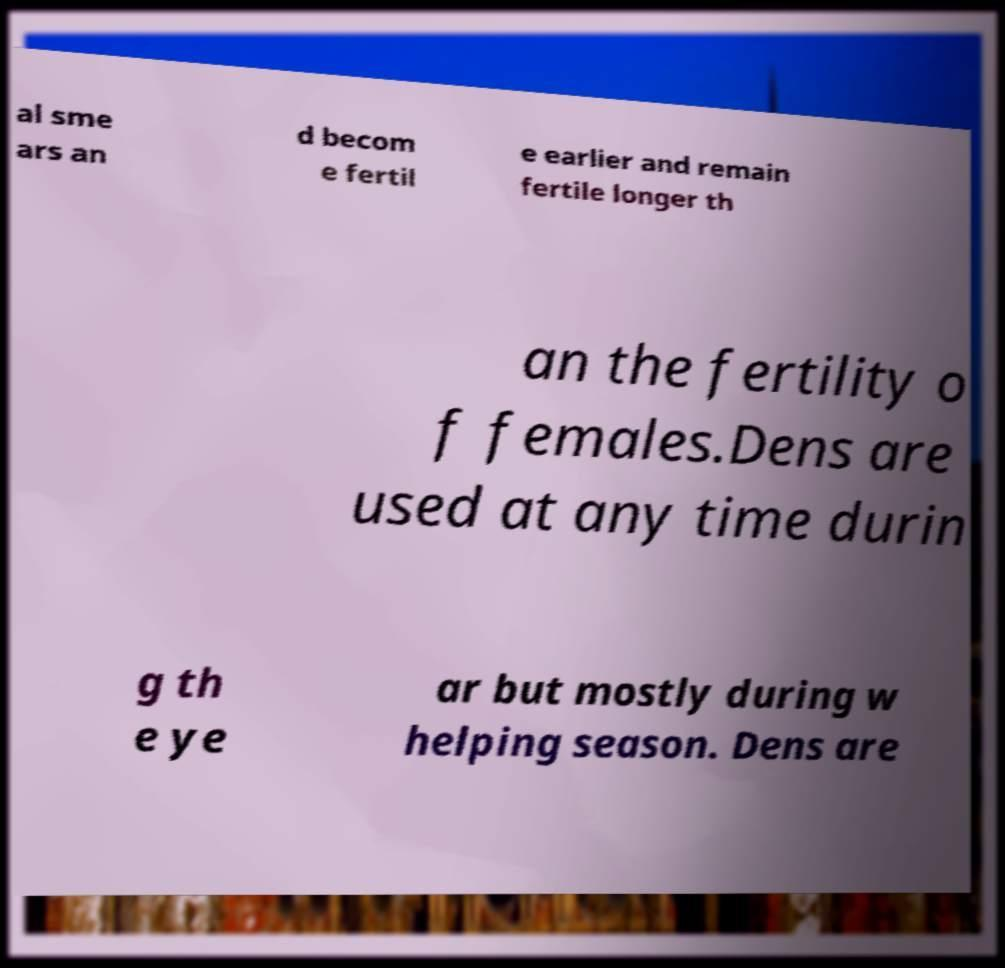I need the written content from this picture converted into text. Can you do that? al sme ars an d becom e fertil e earlier and remain fertile longer th an the fertility o f females.Dens are used at any time durin g th e ye ar but mostly during w helping season. Dens are 